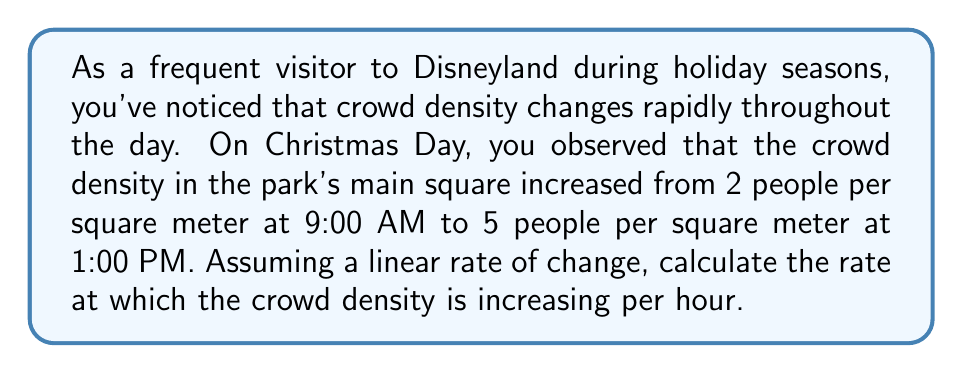Can you solve this math problem? Let's approach this step-by-step:

1) First, let's define our variables:
   $t$ = time in hours
   $\rho$ = crowd density in people per square meter

2) We know two points:
   At 9:00 AM (t = 0): $\rho_0 = 2$ people/m²
   At 1:00 PM (t = 4): $\rho_4 = 5$ people/m²

3) The rate of change is the slope of the line between these two points. We can calculate this using the slope formula:

   $$\text{Rate of change} = \frac{\Delta \rho}{\Delta t} = \frac{\rho_4 - \rho_0}{4 - 0}$$

4) Let's substitute our values:

   $$\text{Rate of change} = \frac{5 - 2}{4 - 0} = \frac{3}{4} = 0.75$$

5) Therefore, the crowd density is increasing at a rate of 0.75 people per square meter per hour.

This information could be valuable for planning your visit times and stock investments in Disney, as crowd levels can impact park experience and potentially correlate with park revenue.
Answer: The rate of change in crowd density is 0.75 people per square meter per hour. 